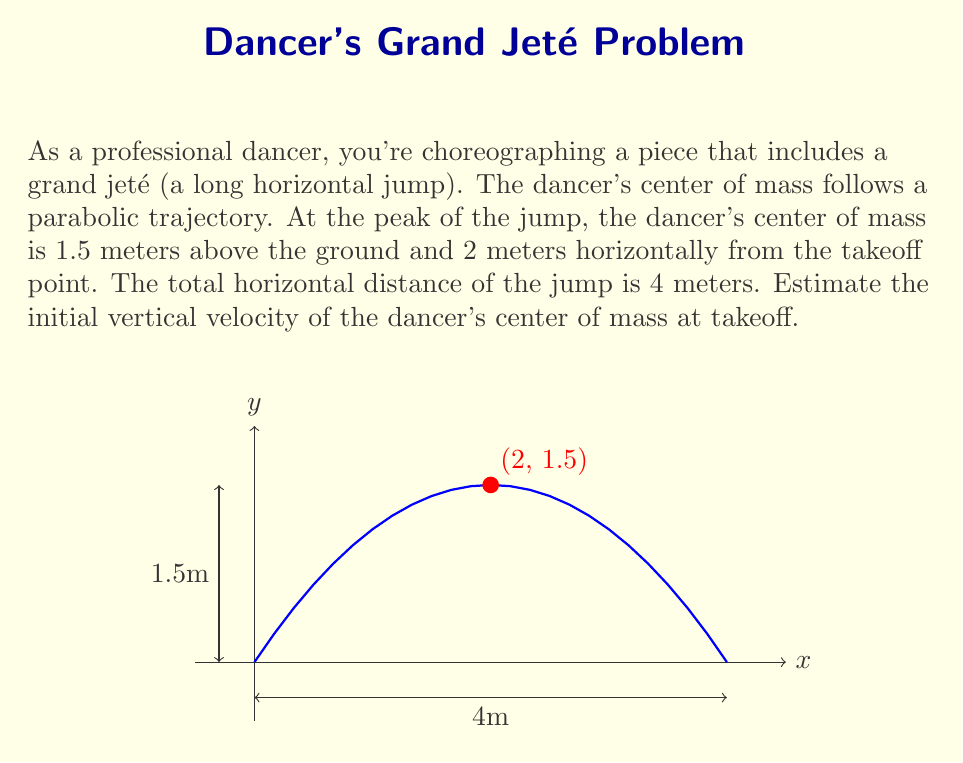What is the answer to this math problem? Let's approach this step-by-step:

1) The trajectory of the center of mass follows a parabolic path described by the equation:

   $$y = -\frac{g}{2v_x^2}x^2 + \frac{v_y}{v_x}x + y_0$$

   where $g$ is the acceleration due to gravity (9.8 m/s²), $v_x$ and $v_y$ are the initial horizontal and vertical velocities, and $y_0$ is the initial height.

2) We know the peak is at (2, 1.5) and the total horizontal distance is 4m. This means:
   
   $$1.5 = -\frac{g}{2v_x^2}(2)^2 + \frac{v_y}{v_x}(2) + 0$$

3) We also know that at x = 4, y = 0:

   $$0 = -\frac{g}{2v_x^2}(4)^2 + \frac{v_y}{v_x}(4) + 0$$

4) From the properties of parabolic motion, we know that the time to reach the peak is half the total time of flight. This means:

   $$v_x = \frac{4}{t} = \frac{4}{\frac{2v_y}{g}} = \frac{2g}{v_y}$$

5) Substituting this into our equation from step 2:

   $$1.5 = -\frac{g}{2(\frac{2g}{v_y})^2}(2)^2 + \frac{v_y}{\frac{2g}{v_y}}(2)$$

6) Simplifying:

   $$1.5 = -\frac{v_y^2}{8g} + \frac{v_y^2}{g}$$

7) Solving for $v_y$:

   $$v_y = \sqrt{\frac{12g}{7}} \approx 4.16 \text{ m/s}$$
Answer: $4.16 \text{ m/s}$ 